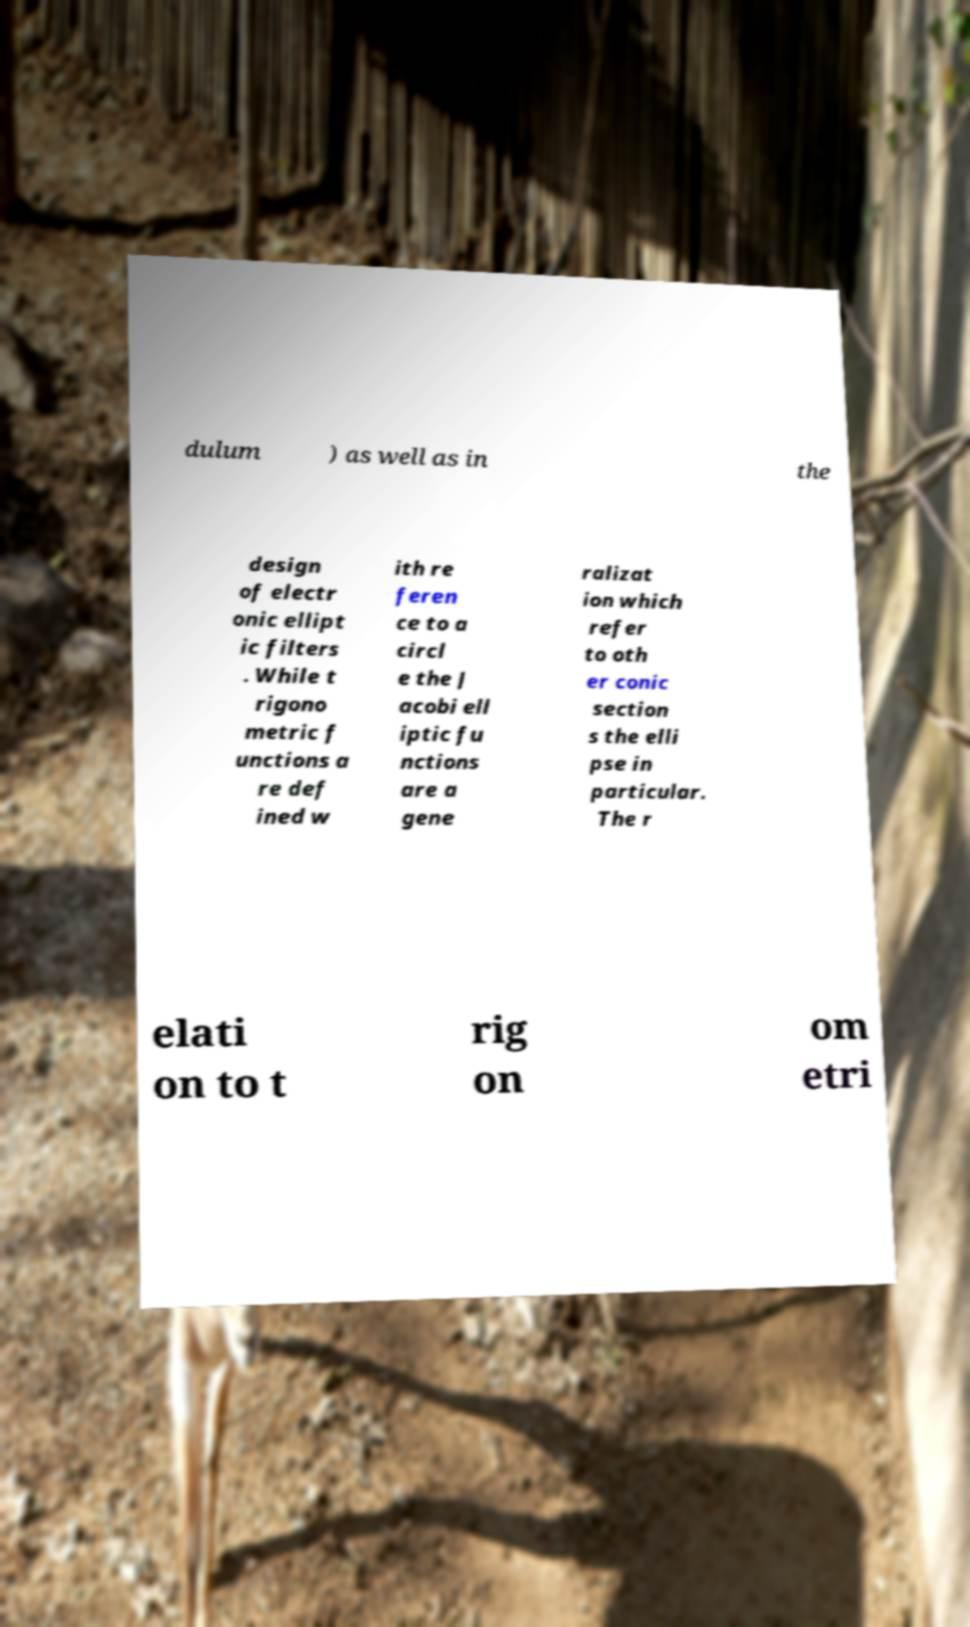Please read and relay the text visible in this image. What does it say? dulum ) as well as in the design of electr onic ellipt ic filters . While t rigono metric f unctions a re def ined w ith re feren ce to a circl e the J acobi ell iptic fu nctions are a gene ralizat ion which refer to oth er conic section s the elli pse in particular. The r elati on to t rig on om etri 